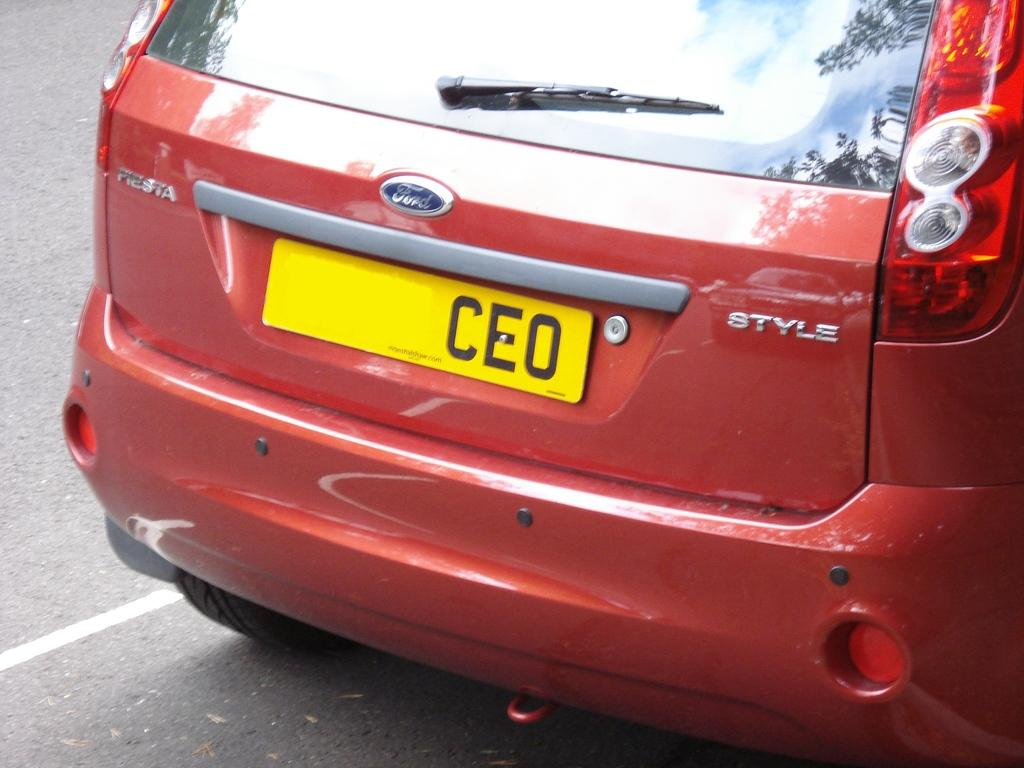<image>
Share a concise interpretation of the image provided. Ford Style logo on a red vehicle with a yellow CEO tag. 